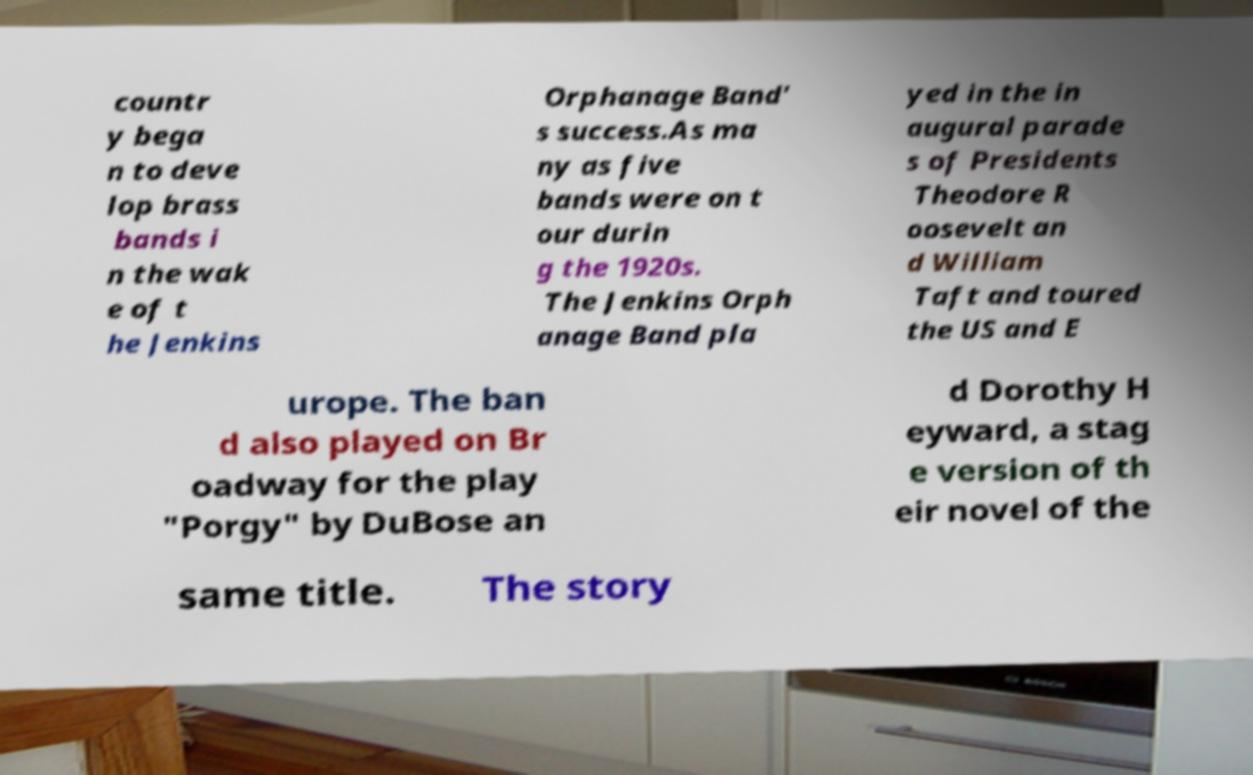Can you accurately transcribe the text from the provided image for me? countr y bega n to deve lop brass bands i n the wak e of t he Jenkins Orphanage Band' s success.As ma ny as five bands were on t our durin g the 1920s. The Jenkins Orph anage Band pla yed in the in augural parade s of Presidents Theodore R oosevelt an d William Taft and toured the US and E urope. The ban d also played on Br oadway for the play "Porgy" by DuBose an d Dorothy H eyward, a stag e version of th eir novel of the same title. The story 